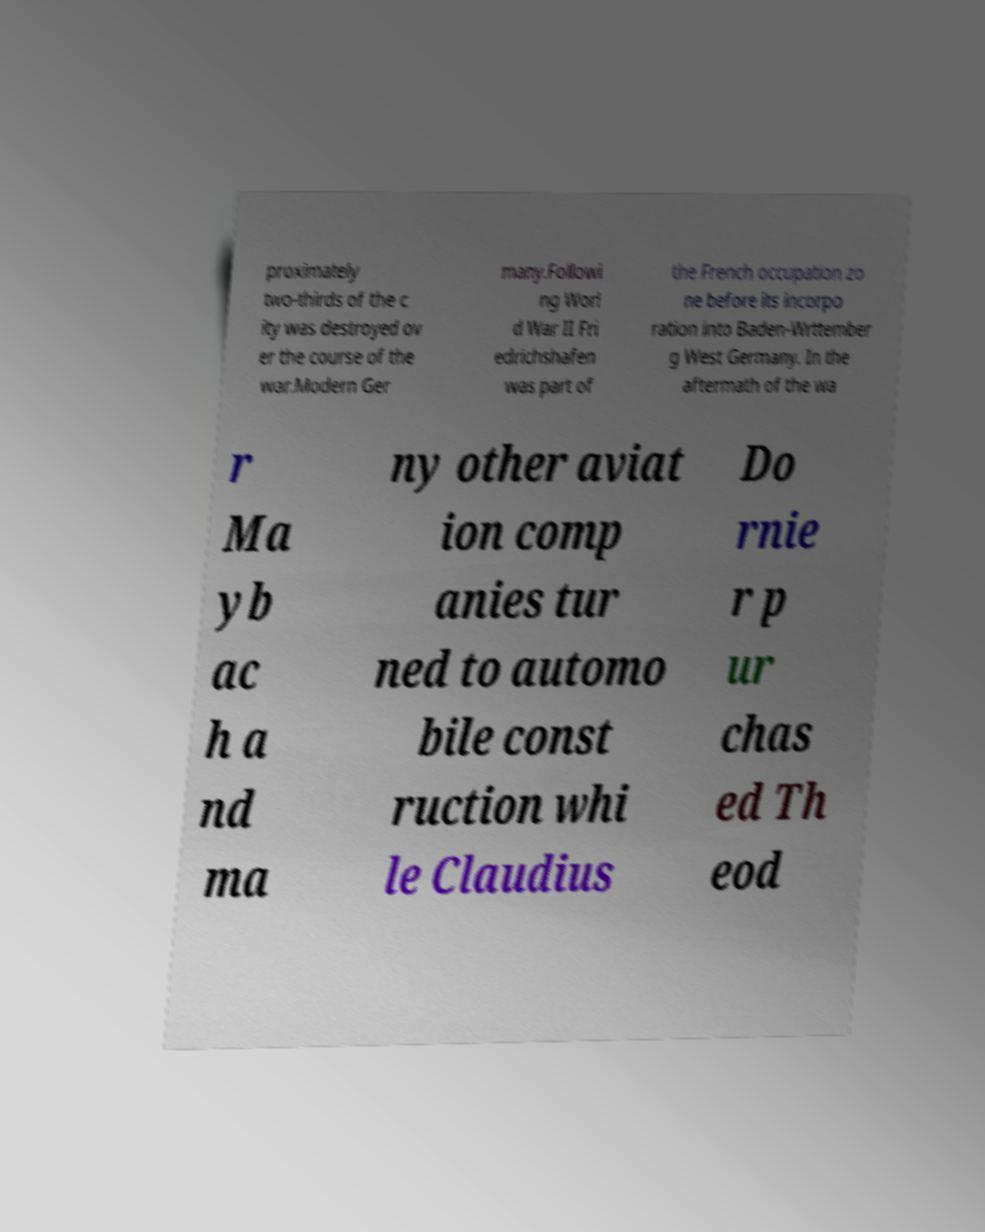Can you read and provide the text displayed in the image?This photo seems to have some interesting text. Can you extract and type it out for me? proximately two-thirds of the c ity was destroyed ov er the course of the war.Modern Ger many.Followi ng Worl d War II Fri edrichshafen was part of the French occupation zo ne before its incorpo ration into Baden-Wrttember g West Germany. In the aftermath of the wa r Ma yb ac h a nd ma ny other aviat ion comp anies tur ned to automo bile const ruction whi le Claudius Do rnie r p ur chas ed Th eod 